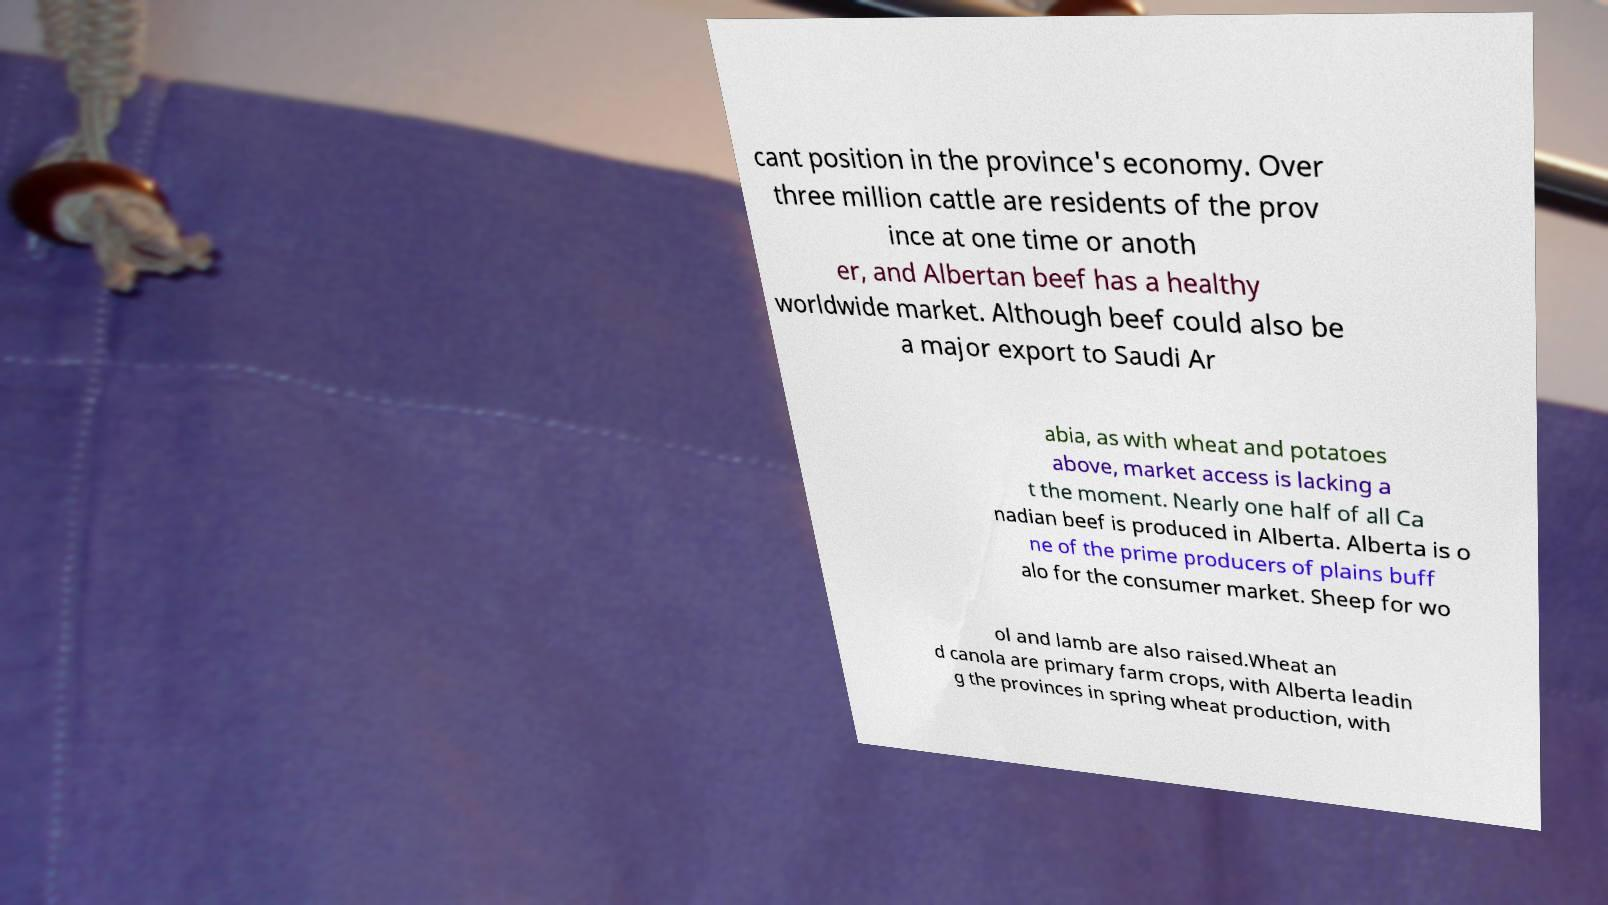Can you read and provide the text displayed in the image?This photo seems to have some interesting text. Can you extract and type it out for me? cant position in the province's economy. Over three million cattle are residents of the prov ince at one time or anoth er, and Albertan beef has a healthy worldwide market. Although beef could also be a major export to Saudi Ar abia, as with wheat and potatoes above, market access is lacking a t the moment. Nearly one half of all Ca nadian beef is produced in Alberta. Alberta is o ne of the prime producers of plains buff alo for the consumer market. Sheep for wo ol and lamb are also raised.Wheat an d canola are primary farm crops, with Alberta leadin g the provinces in spring wheat production, with 